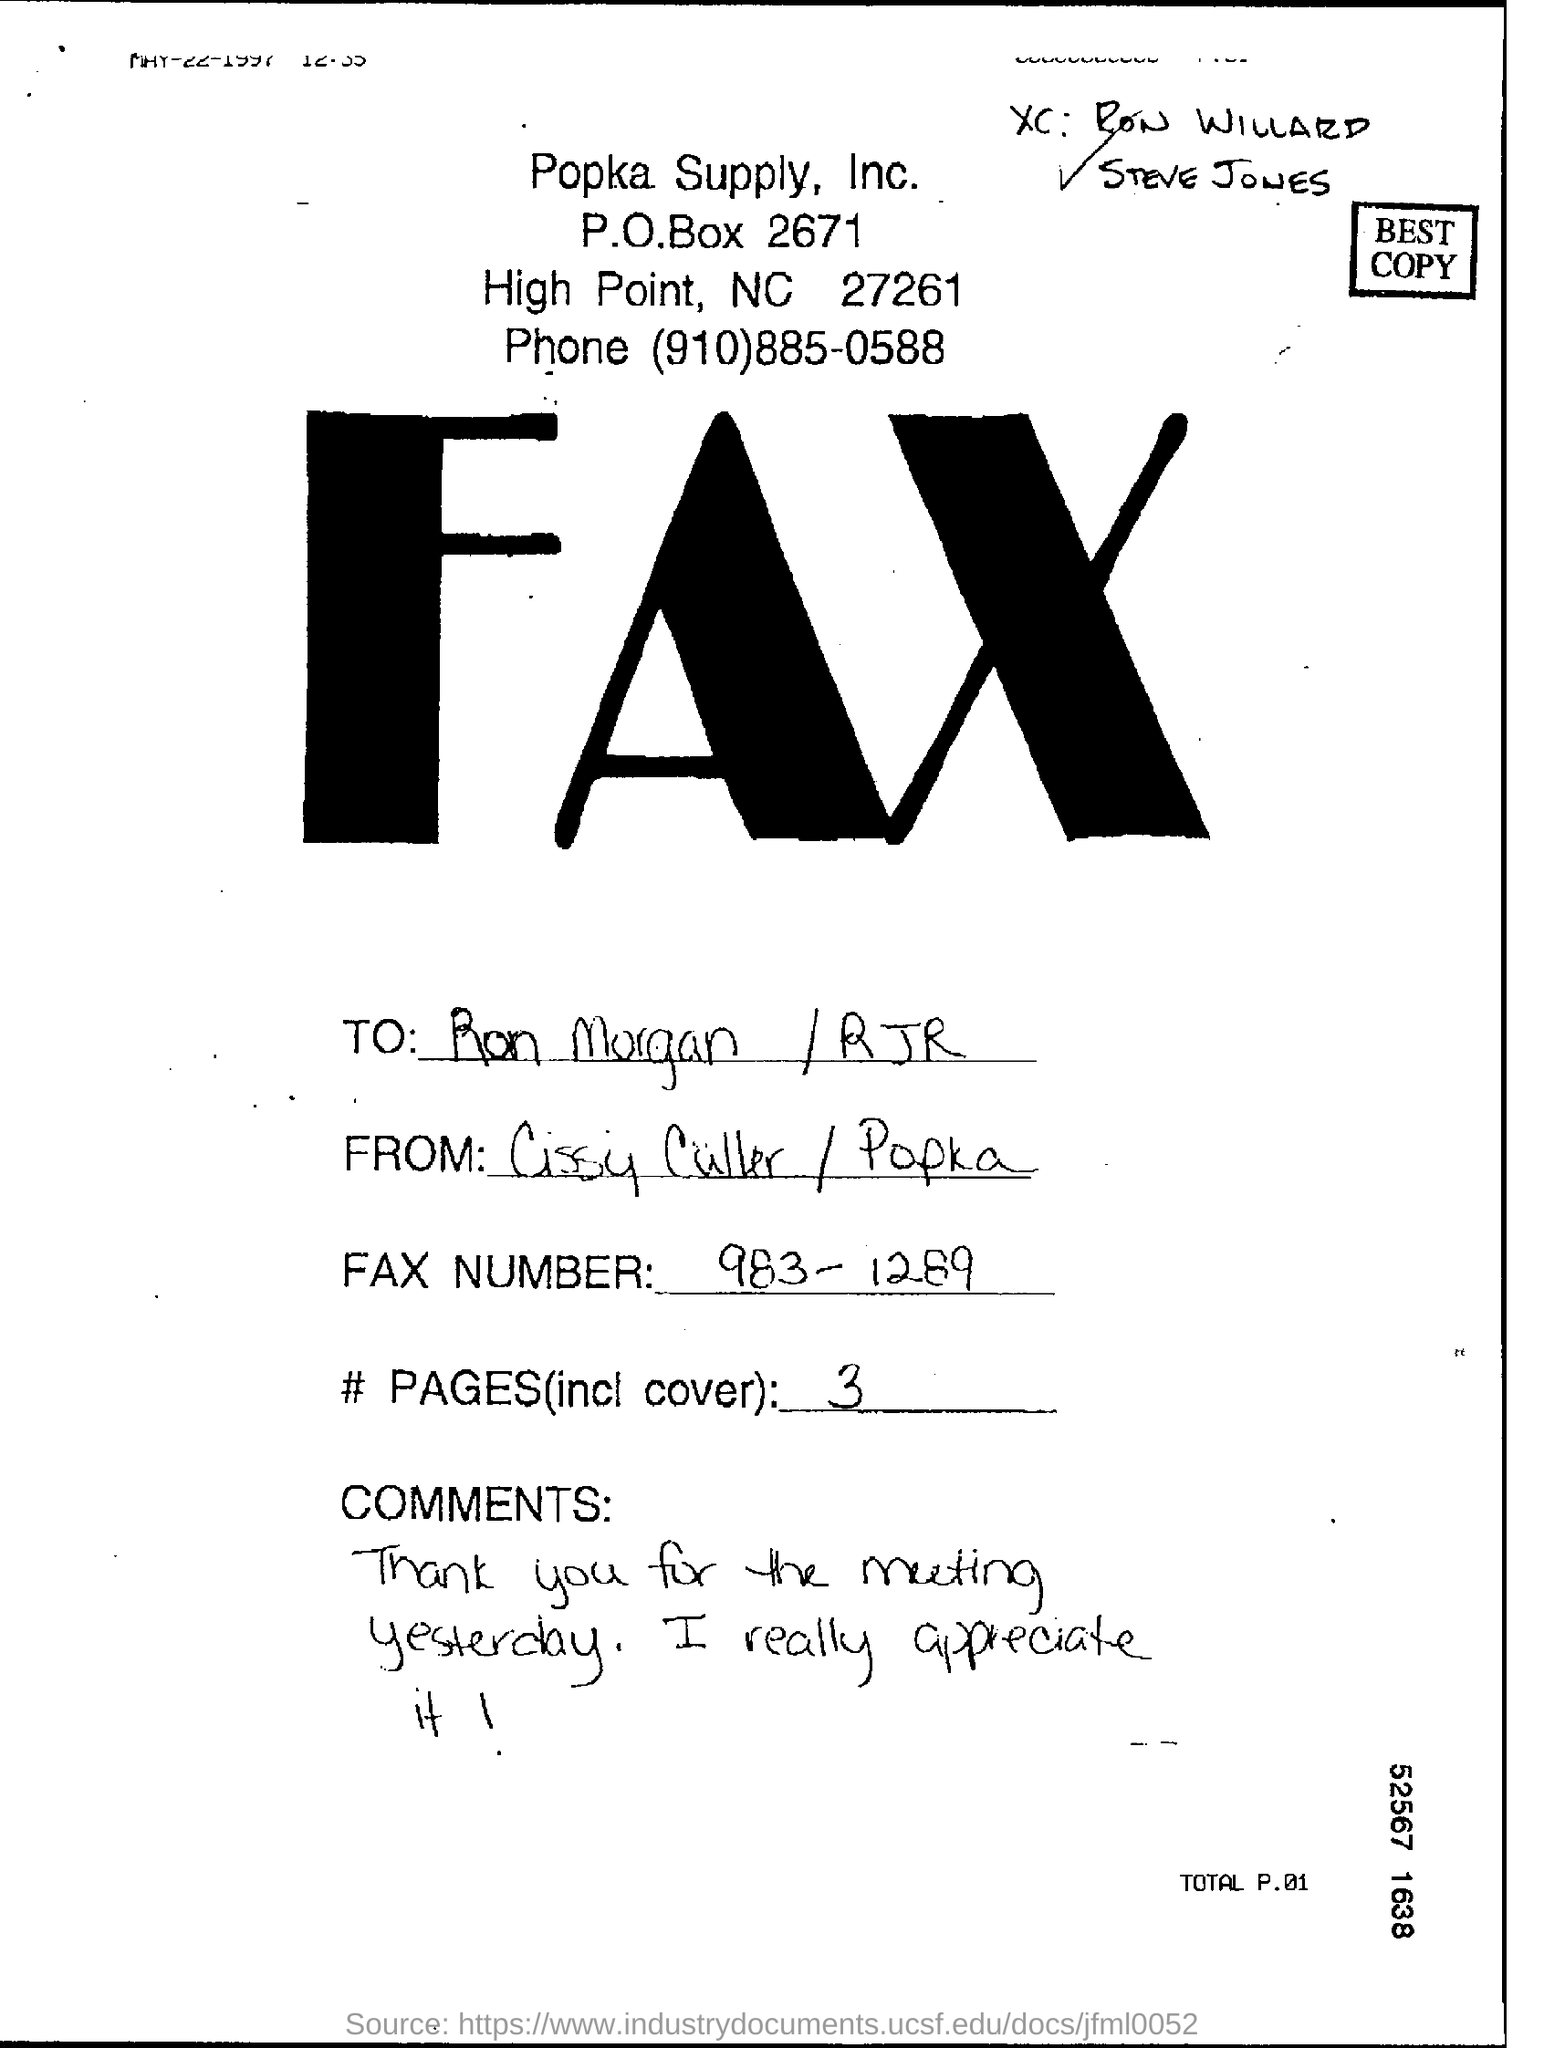Who is the fax addressed to?
Offer a terse response. Ron Morgan /RJR. How many pages are there including cover?
Provide a succinct answer. 3. Which company's name is at the top of the page?
Provide a succinct answer. Popka Supply, Inc. 